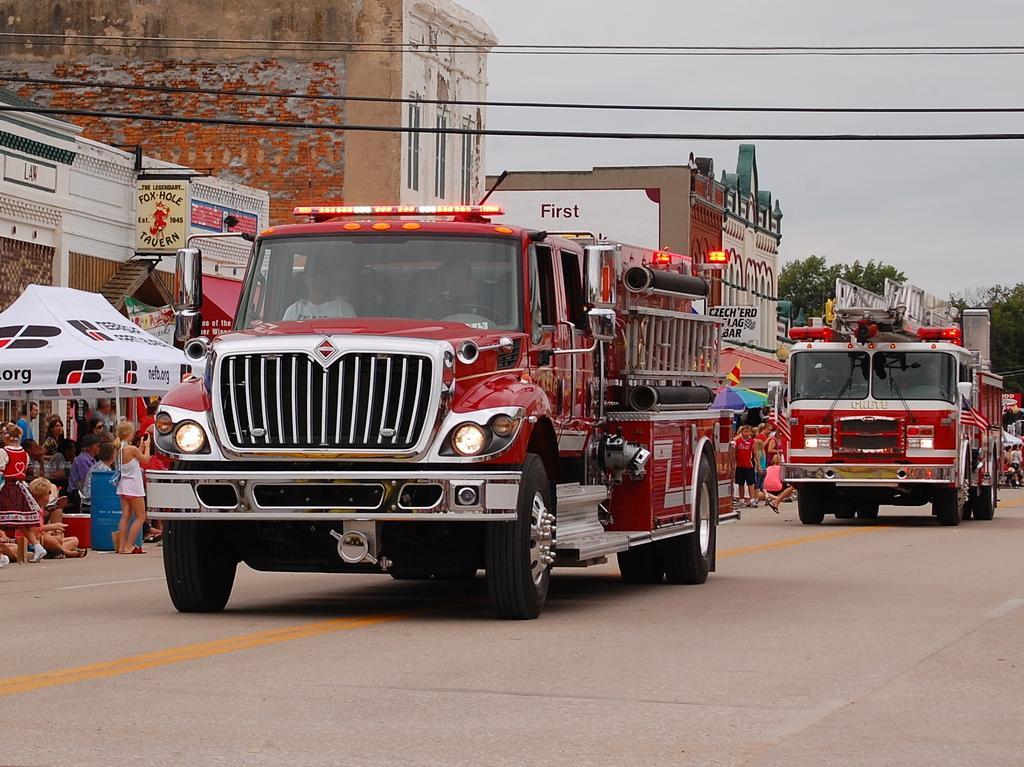In one or two sentences, can you explain what this image depicts? In the image on the road there are fire engines. Behind them there are few people. And also there are tents. In the background there are buildings with walls, windows, roofs, stores and name boards. In the background there are trees. At the top of the image there are wires. 